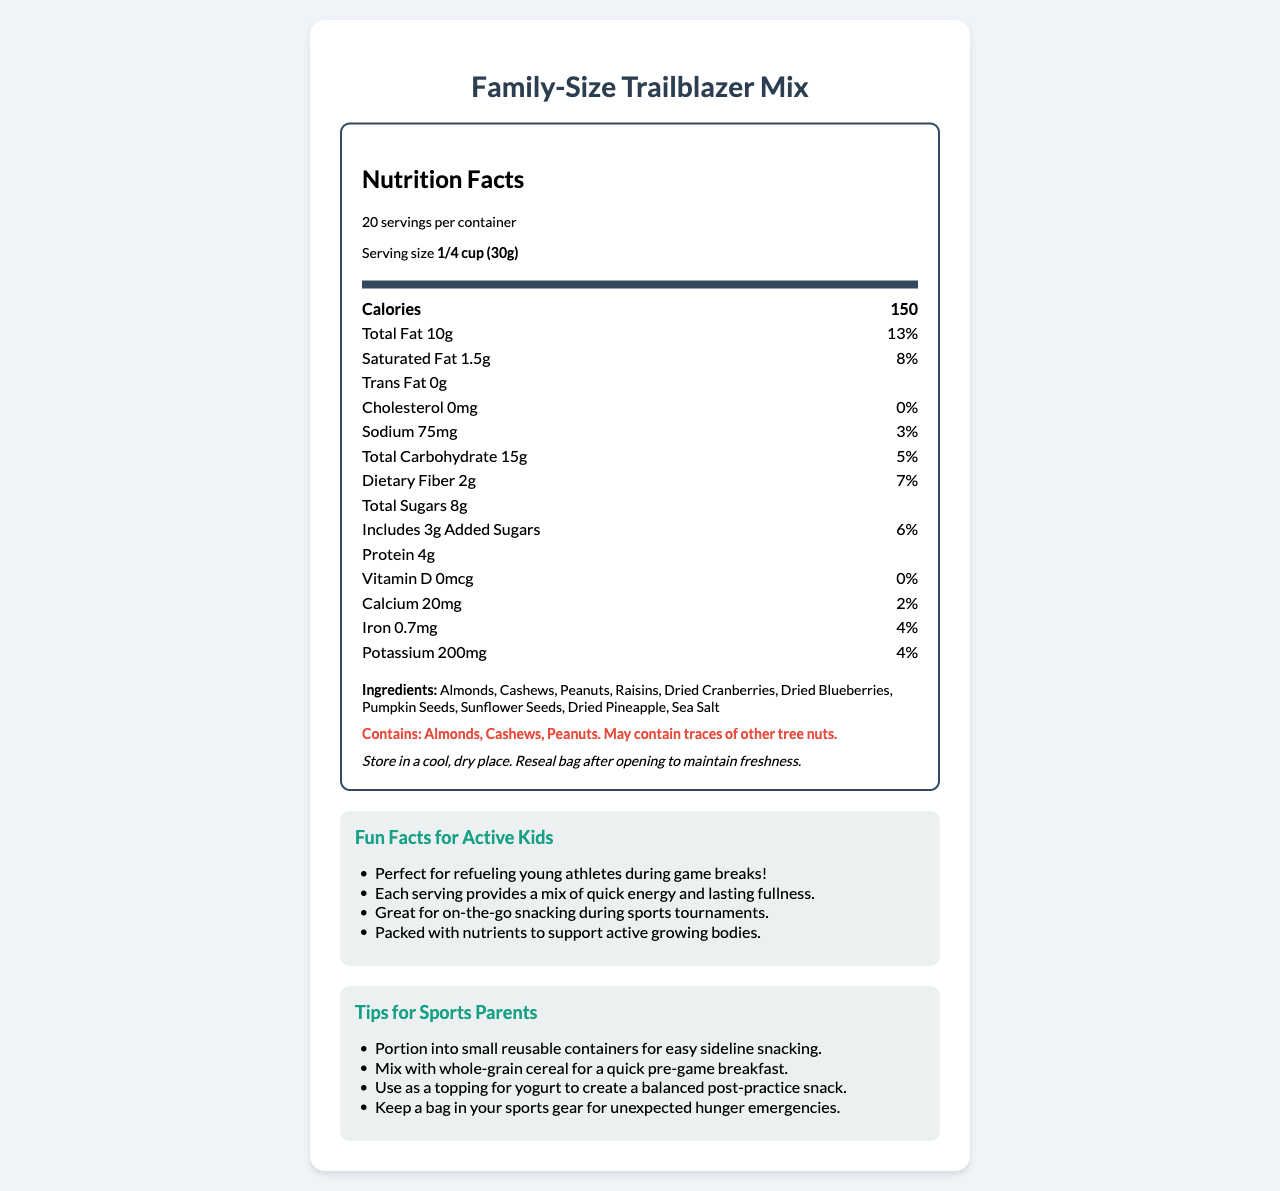what is the serving size? The document specifies that the serving size is 1/4 cup or 30 grams.
Answer: 1/4 cup (30g) how many servings are in the container? The document states that there are 20 servings per container.
Answer: 20 What is the calorie count per serving? Each serving contains 150 calories as mentioned in the document.
Answer: 150 calories How much protein is in one serving? The document lists that one serving has 4 grams of protein.
Answer: 4g What types of nuts are included in the trail mix? The ingredients section lists Almonds, Cashews, and Peanuts as part of the trail mix.
Answer: Almonds, Cashews, Peanuts What percentage of daily value does the total fat content represent? The total fat content is 10g per serving, which represents 13% of the daily value.
Answer: 13% what is the amount of dietary fiber per serving? According to the document, there are 2 grams of dietary fiber per serving.
Answer: 2g How many grams of added sugars are in this trail mix? The document states that each serving includes 3 grams of added sugars.
Answer: 3g What are some dried fruits included in the trail mix? The ingredients section lists these dried fruits.
Answer: Raisins, Dried Cranberries, Dried Blueberries, Dried Pineapple What is the sodium content per serving? A. 50mg B. 75mg C. 100mg D. 125mg The sodium content per serving is listed as 75mg in the document.
Answer: B. 75mg Which of the following vitamins and minerals is not present in this trail mix? I. Vitamin D II. Calcium III. Iron The document states that Vitamin D is 0mcg, implying it is not present.
Answer: I. Vitamin D Does the product contain trans fat? The document lists the trans fat amount as 0g, indicating there are no trans fats in the product.
Answer: No Is this trail mix suitable for someone with a peanut allergy? The allergen information specifies that the product contains Almonds, Cashews, and Peanuts.
Answer: No Summarize the main idea of the document. The document comprehensively covers the nutrition facts, ingredient list, allergen warnings, and extra information that may interest parents who are looking for convenient and healthy snacks for their children’s sports activities.
Answer: The document provides detailed nutritional information for a family-size pack of trail mix, highlighting the calorie content, the variety of nuts and dried fruits included, as well as allergen information, storage instructions, fun facts, and tips for sports parents. How much dietary fiber is in two servings of trail mix? Each serving contains 2 grams of dietary fiber; therefore, two servings would contain 4 grams in total.
Answer: 4g What is the recommended storage instruction for this trail mix? The storage instruction is clearly mentioned as storing in a cool, dry place and resealing the bag after opening.
Answer: Store in a cool, dry place. Reseal bag after opening to maintain freshness. Can this product supply 100% of your daily iron needs? The document indicates that one serving only provides 4% of the daily value of iron, so one would need 25 servings to meet 100% of the daily iron needs, which is impractical.
Answer: No What color is the background of the container in the document? The document does not provide any visual description of the container’s background color.
Answer: Not enough information 